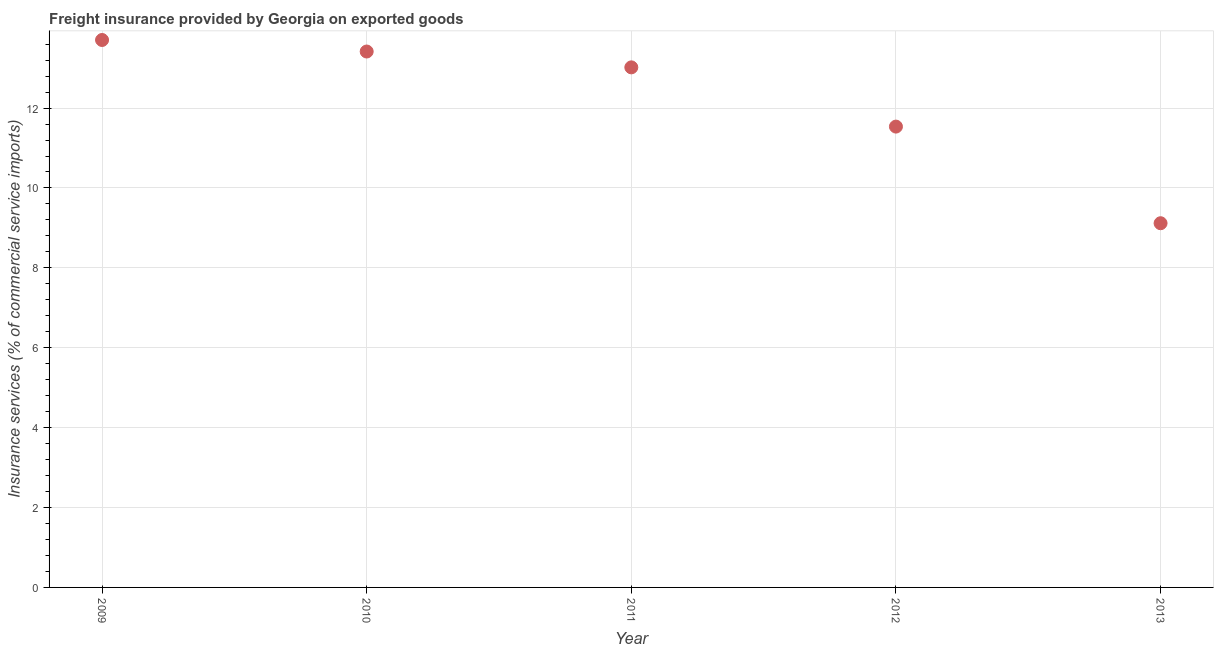What is the freight insurance in 2009?
Keep it short and to the point. 13.7. Across all years, what is the maximum freight insurance?
Your response must be concise. 13.7. Across all years, what is the minimum freight insurance?
Ensure brevity in your answer.  9.12. What is the sum of the freight insurance?
Keep it short and to the point. 60.79. What is the difference between the freight insurance in 2011 and 2012?
Provide a short and direct response. 1.48. What is the average freight insurance per year?
Your response must be concise. 12.16. What is the median freight insurance?
Provide a succinct answer. 13.02. In how many years, is the freight insurance greater than 6 %?
Keep it short and to the point. 5. What is the ratio of the freight insurance in 2009 to that in 2010?
Offer a terse response. 1.02. Is the freight insurance in 2010 less than that in 2013?
Make the answer very short. No. What is the difference between the highest and the second highest freight insurance?
Ensure brevity in your answer.  0.29. Is the sum of the freight insurance in 2012 and 2013 greater than the maximum freight insurance across all years?
Your answer should be very brief. Yes. What is the difference between the highest and the lowest freight insurance?
Keep it short and to the point. 4.59. Does the freight insurance monotonically increase over the years?
Provide a short and direct response. No. How many dotlines are there?
Provide a short and direct response. 1. How many years are there in the graph?
Offer a very short reply. 5. What is the difference between two consecutive major ticks on the Y-axis?
Provide a short and direct response. 2. Does the graph contain grids?
Ensure brevity in your answer.  Yes. What is the title of the graph?
Give a very brief answer. Freight insurance provided by Georgia on exported goods . What is the label or title of the Y-axis?
Keep it short and to the point. Insurance services (% of commercial service imports). What is the Insurance services (% of commercial service imports) in 2009?
Provide a short and direct response. 13.7. What is the Insurance services (% of commercial service imports) in 2010?
Offer a terse response. 13.42. What is the Insurance services (% of commercial service imports) in 2011?
Your answer should be compact. 13.02. What is the Insurance services (% of commercial service imports) in 2012?
Keep it short and to the point. 11.54. What is the Insurance services (% of commercial service imports) in 2013?
Offer a very short reply. 9.12. What is the difference between the Insurance services (% of commercial service imports) in 2009 and 2010?
Keep it short and to the point. 0.29. What is the difference between the Insurance services (% of commercial service imports) in 2009 and 2011?
Your answer should be very brief. 0.69. What is the difference between the Insurance services (% of commercial service imports) in 2009 and 2012?
Offer a very short reply. 2.17. What is the difference between the Insurance services (% of commercial service imports) in 2009 and 2013?
Your answer should be compact. 4.59. What is the difference between the Insurance services (% of commercial service imports) in 2010 and 2011?
Provide a succinct answer. 0.4. What is the difference between the Insurance services (% of commercial service imports) in 2010 and 2012?
Ensure brevity in your answer.  1.88. What is the difference between the Insurance services (% of commercial service imports) in 2010 and 2013?
Offer a terse response. 4.3. What is the difference between the Insurance services (% of commercial service imports) in 2011 and 2012?
Ensure brevity in your answer.  1.48. What is the difference between the Insurance services (% of commercial service imports) in 2011 and 2013?
Keep it short and to the point. 3.9. What is the difference between the Insurance services (% of commercial service imports) in 2012 and 2013?
Offer a very short reply. 2.42. What is the ratio of the Insurance services (% of commercial service imports) in 2009 to that in 2011?
Provide a short and direct response. 1.05. What is the ratio of the Insurance services (% of commercial service imports) in 2009 to that in 2012?
Offer a very short reply. 1.19. What is the ratio of the Insurance services (% of commercial service imports) in 2009 to that in 2013?
Offer a very short reply. 1.5. What is the ratio of the Insurance services (% of commercial service imports) in 2010 to that in 2011?
Ensure brevity in your answer.  1.03. What is the ratio of the Insurance services (% of commercial service imports) in 2010 to that in 2012?
Offer a very short reply. 1.16. What is the ratio of the Insurance services (% of commercial service imports) in 2010 to that in 2013?
Give a very brief answer. 1.47. What is the ratio of the Insurance services (% of commercial service imports) in 2011 to that in 2012?
Your answer should be very brief. 1.13. What is the ratio of the Insurance services (% of commercial service imports) in 2011 to that in 2013?
Offer a very short reply. 1.43. What is the ratio of the Insurance services (% of commercial service imports) in 2012 to that in 2013?
Your response must be concise. 1.26. 